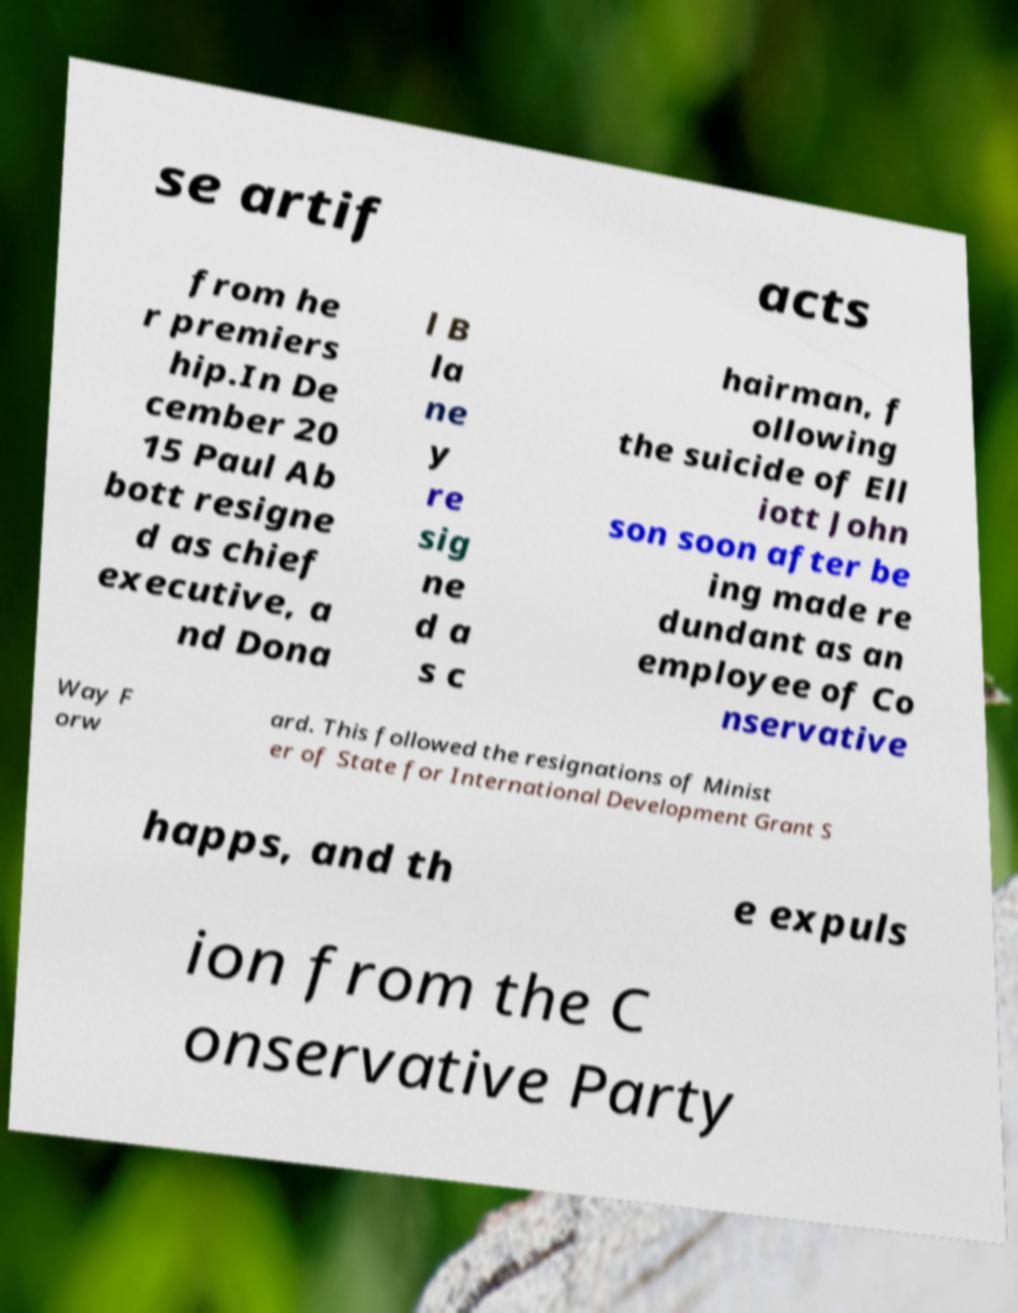What messages or text are displayed in this image? I need them in a readable, typed format. se artif acts from he r premiers hip.In De cember 20 15 Paul Ab bott resigne d as chief executive, a nd Dona l B la ne y re sig ne d a s c hairman, f ollowing the suicide of Ell iott John son soon after be ing made re dundant as an employee of Co nservative Way F orw ard. This followed the resignations of Minist er of State for International Development Grant S happs, and th e expuls ion from the C onservative Party 